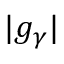<formula> <loc_0><loc_0><loc_500><loc_500>| g _ { \gamma } |</formula> 